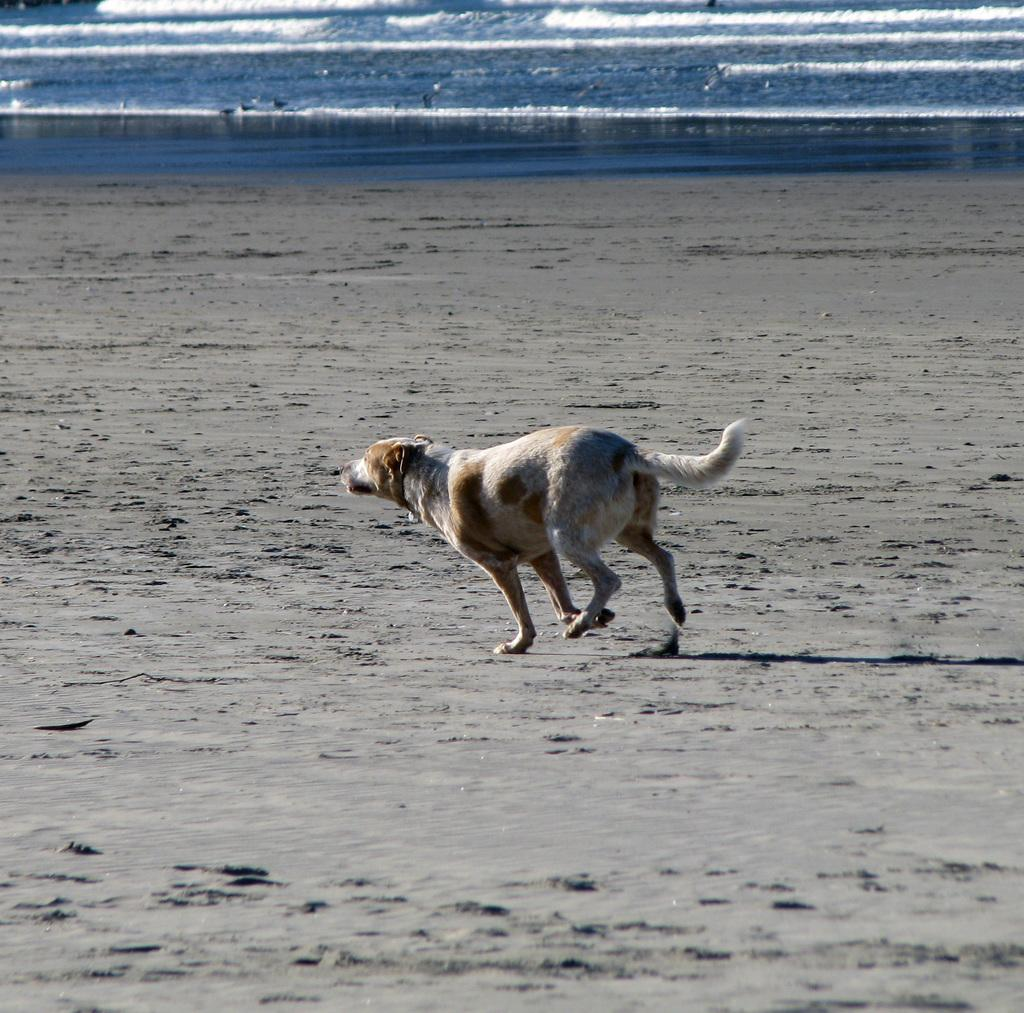What animal can be seen in the image? There is a dog in the image. What is the dog doing in the image? The dog is running. What type of environment is visible in the image? There is water visible at the top of the image and soil visible in the background. What type of baseball equipment can be seen in the image? There is no baseball equipment present in the image. How does the dog show respect to the other animals in the image? There are no other animals present in the image, and the concept of respect is not applicable to dogs in this context. 